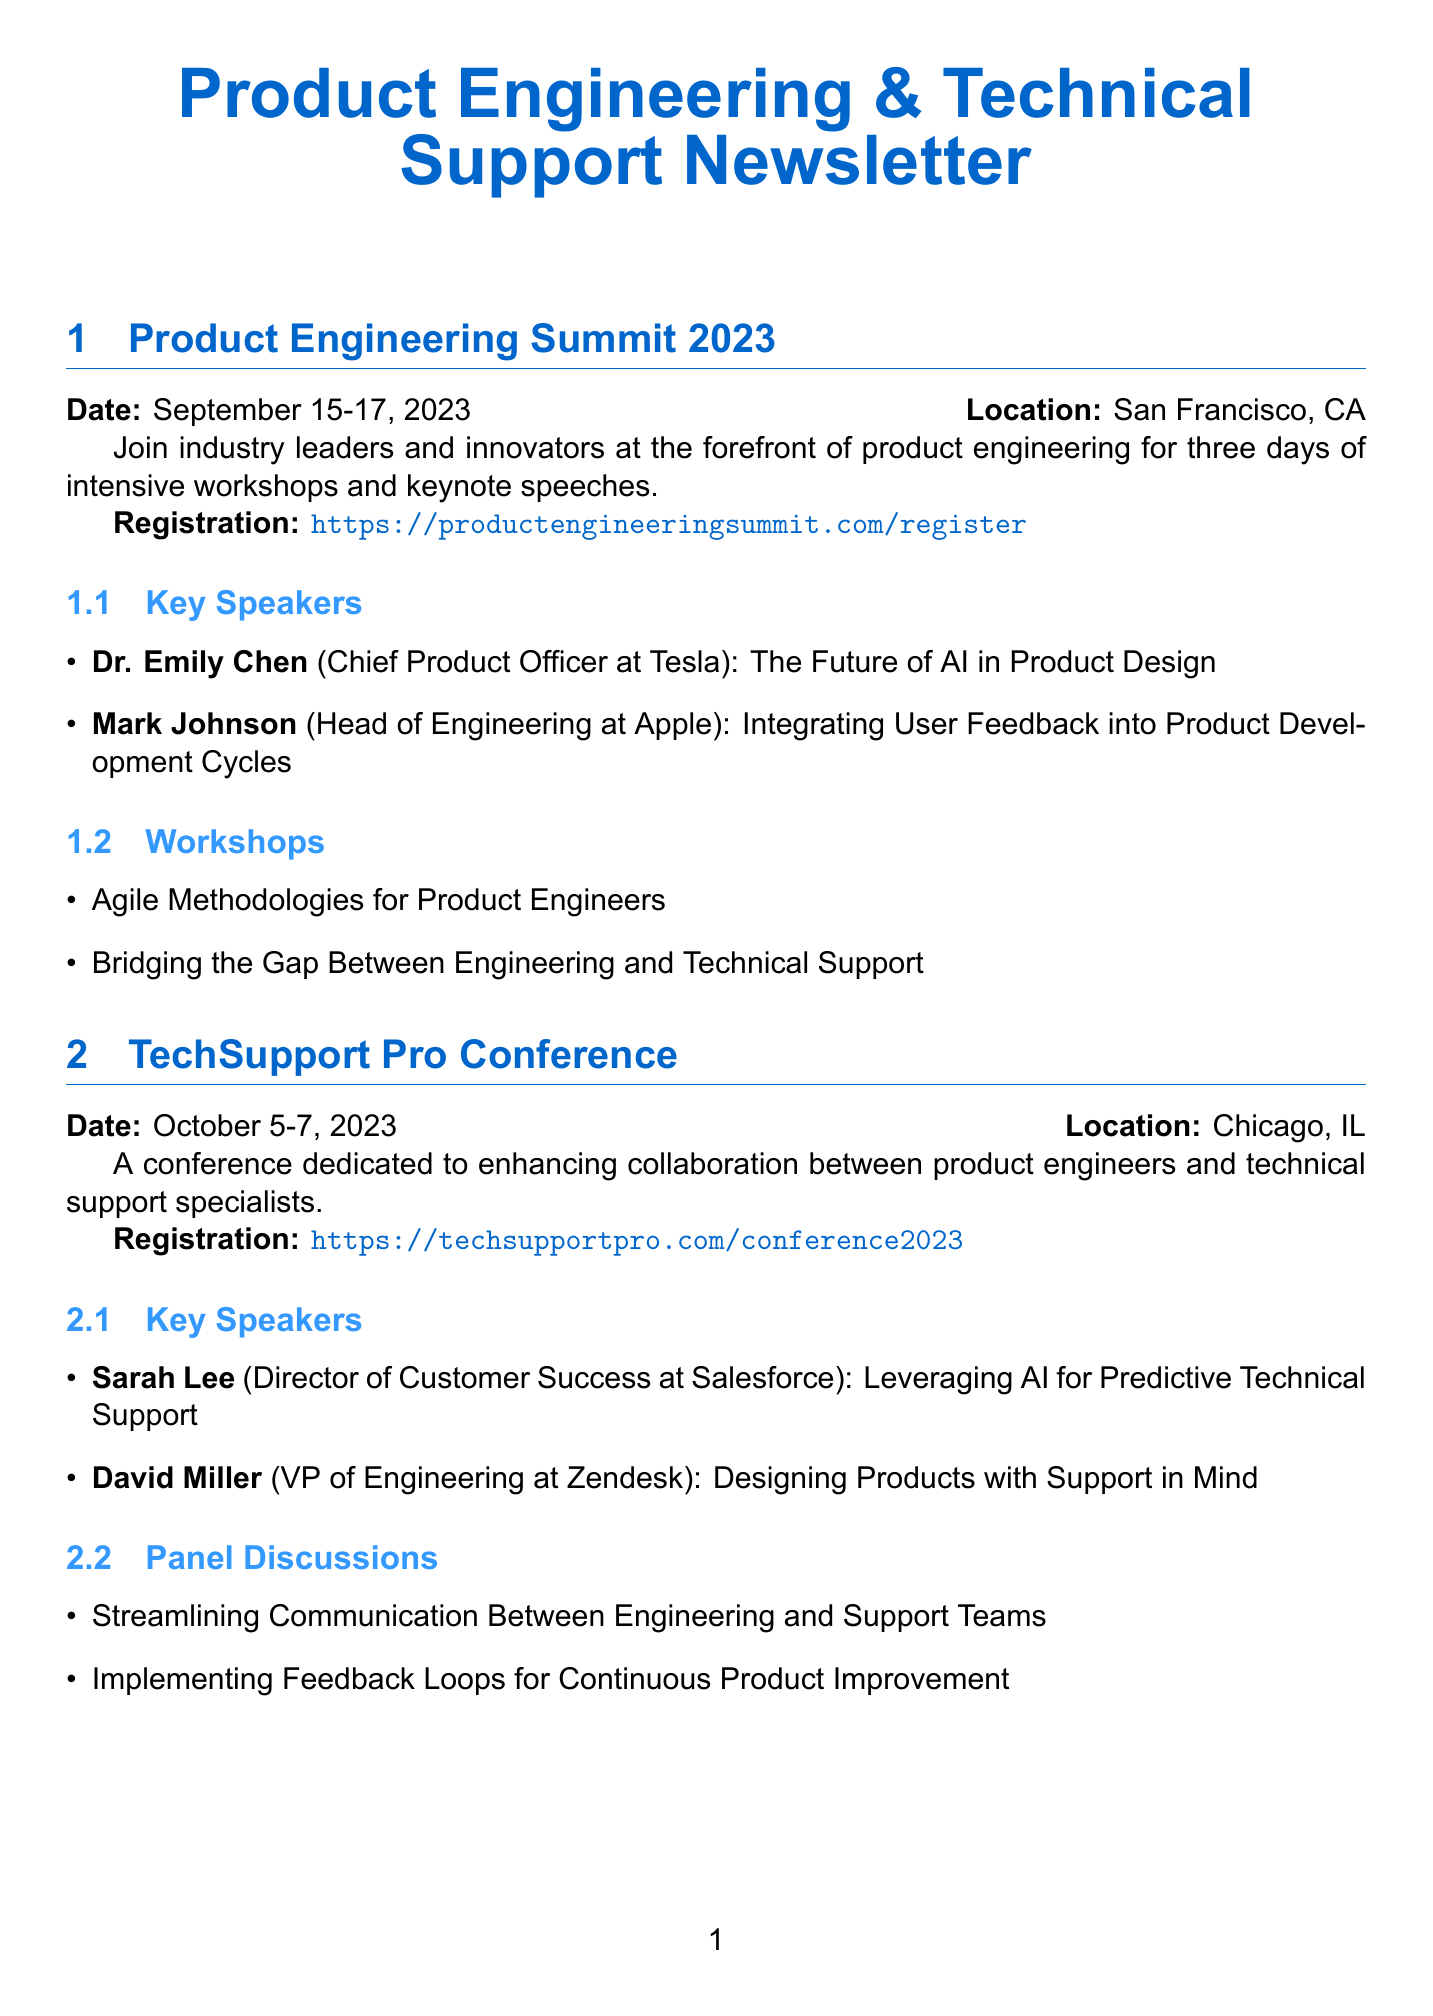What is the date of the Product Engineering Summit 2023? The date is specified in the document for the Product Engineering Summit, which is September 15-17, 2023.
Answer: September 15-17, 2023 Where is the TechSupport Pro Conference being held? The location for the TechSupport Pro Conference is provided in the document as Chicago, IL.
Answer: Chicago, IL Who are the key speakers at the IEEE International Conference on Product Engineering? The document lists Prof. Akira Tanaka and Dr. Maria Garcia as the key speakers for the IEEE International Conference on Product Engineering.
Answer: Prof. Akira Tanaka, Dr. Maria Garcia What topic will Dr. Emily Chen cover at the Product Engineering Summit? The document notes that Dr. Emily Chen will speak on "The Future of AI in Product Design" at the event.
Answer: The Future of AI in Product Design How many workshop modules are in the Product Support Excellence Workshop? The document explicitly states that there are three workshop modules listed in the Product Support Excellence Workshop section.
Answer: Three What is the main focus of the TechSupport Pro Conference? The document describes the main focus as enhancing collaboration between product engineers and technical support specialists.
Answer: Enhancing collaboration When does the Product Support Excellence Workshop take place? The document provides the dates for the Product Support Excellence Workshop as December 1-2, 2023.
Answer: December 1-2, 2023 Which facilitator will discuss building cross-functional teams at the Product Support Excellence Workshop? According to the document, Jennifer Zhao will discuss building cross-functional teams for optimal product support in the workshop.
Answer: Jennifer Zhao What is the registration link for the IEEE International Conference on Product Engineering? The document states the registration link for the IEEE International Conference as https://ieee.org/conferences/product-engineering-2023.
Answer: https://ieee.org/conferences/product-engineering-2023 